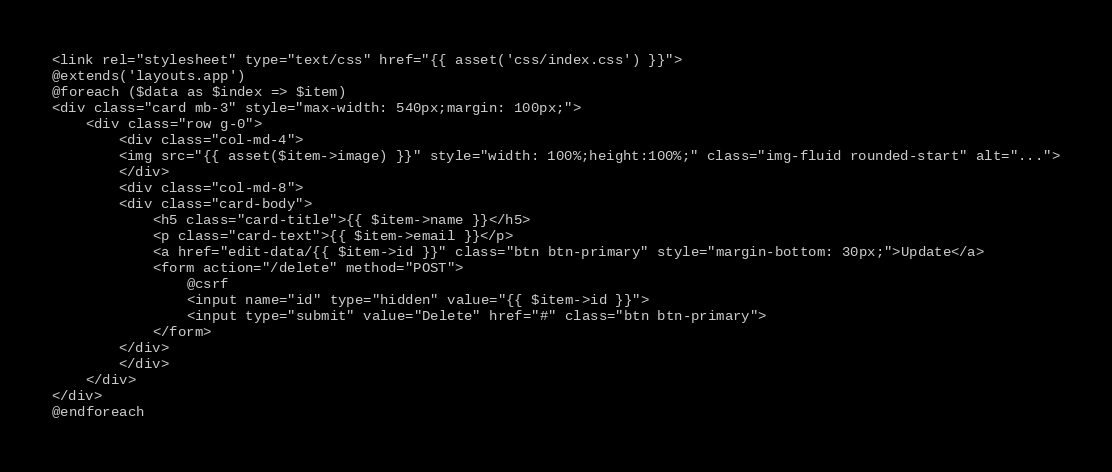<code> <loc_0><loc_0><loc_500><loc_500><_PHP_><link rel="stylesheet" type="text/css" href="{{ asset('css/index.css') }}">
@extends('layouts.app')
@foreach ($data as $index => $item)
<div class="card mb-3" style="max-width: 540px;margin: 100px;">
    <div class="row g-0">
        <div class="col-md-4">
        <img src="{{ asset($item->image) }}" style="width: 100%;height:100%;" class="img-fluid rounded-start" alt="...">
        </div>
        <div class="col-md-8">
        <div class="card-body">
            <h5 class="card-title">{{ $item->name }}</h5>
            <p class="card-text">{{ $item->email }}</p>
            <a href="edit-data/{{ $item->id }}" class="btn btn-primary" style="margin-bottom: 30px;">Update</a>
            <form action="/delete" method="POST">
                @csrf
                <input name="id" type="hidden" value="{{ $item->id }}">
                <input type="submit" value="Delete" href="#" class="btn btn-primary">
            </form>
        </div>
        </div>
    </div>
</div>
@endforeach
</code> 